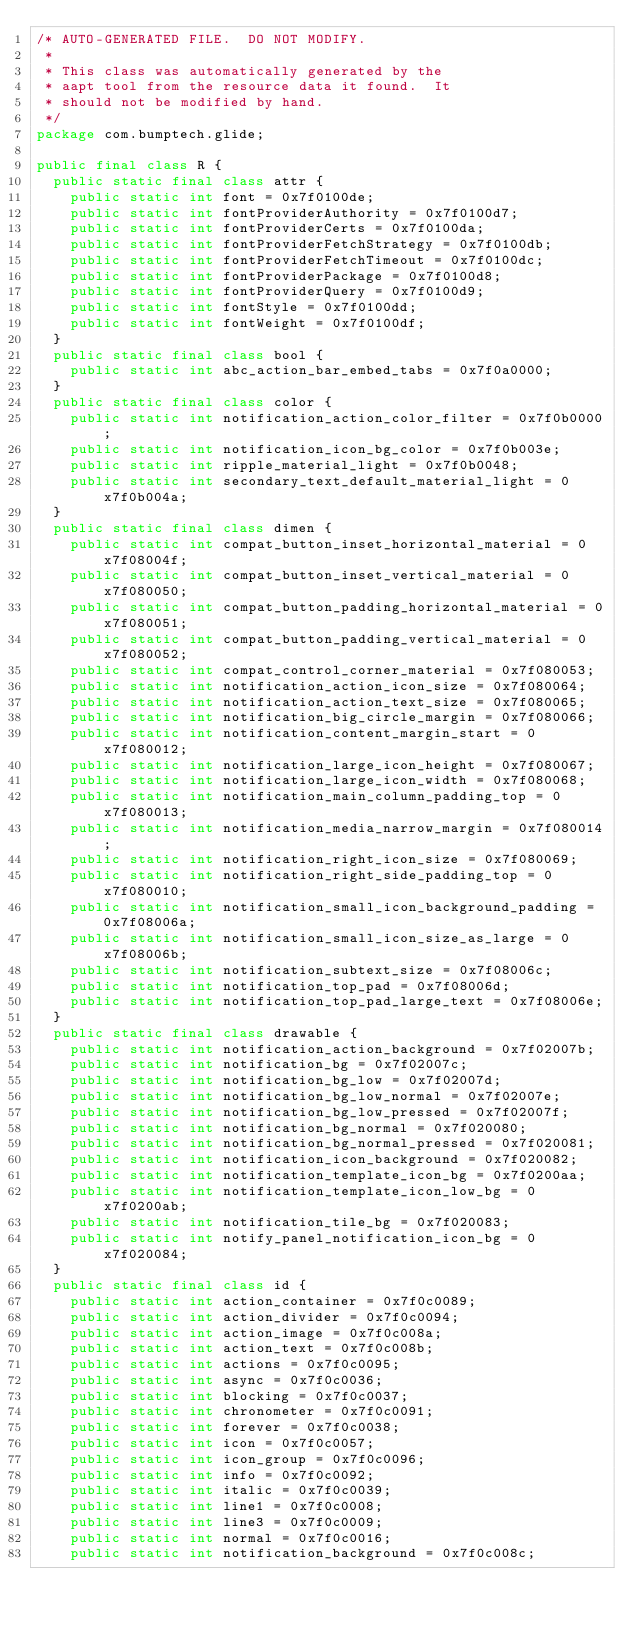<code> <loc_0><loc_0><loc_500><loc_500><_Java_>/* AUTO-GENERATED FILE.  DO NOT MODIFY.
 *
 * This class was automatically generated by the
 * aapt tool from the resource data it found.  It
 * should not be modified by hand.
 */
package com.bumptech.glide;

public final class R {
	public static final class attr {
		public static int font = 0x7f0100de;
		public static int fontProviderAuthority = 0x7f0100d7;
		public static int fontProviderCerts = 0x7f0100da;
		public static int fontProviderFetchStrategy = 0x7f0100db;
		public static int fontProviderFetchTimeout = 0x7f0100dc;
		public static int fontProviderPackage = 0x7f0100d8;
		public static int fontProviderQuery = 0x7f0100d9;
		public static int fontStyle = 0x7f0100dd;
		public static int fontWeight = 0x7f0100df;
	}
	public static final class bool {
		public static int abc_action_bar_embed_tabs = 0x7f0a0000;
	}
	public static final class color {
		public static int notification_action_color_filter = 0x7f0b0000;
		public static int notification_icon_bg_color = 0x7f0b003e;
		public static int ripple_material_light = 0x7f0b0048;
		public static int secondary_text_default_material_light = 0x7f0b004a;
	}
	public static final class dimen {
		public static int compat_button_inset_horizontal_material = 0x7f08004f;
		public static int compat_button_inset_vertical_material = 0x7f080050;
		public static int compat_button_padding_horizontal_material = 0x7f080051;
		public static int compat_button_padding_vertical_material = 0x7f080052;
		public static int compat_control_corner_material = 0x7f080053;
		public static int notification_action_icon_size = 0x7f080064;
		public static int notification_action_text_size = 0x7f080065;
		public static int notification_big_circle_margin = 0x7f080066;
		public static int notification_content_margin_start = 0x7f080012;
		public static int notification_large_icon_height = 0x7f080067;
		public static int notification_large_icon_width = 0x7f080068;
		public static int notification_main_column_padding_top = 0x7f080013;
		public static int notification_media_narrow_margin = 0x7f080014;
		public static int notification_right_icon_size = 0x7f080069;
		public static int notification_right_side_padding_top = 0x7f080010;
		public static int notification_small_icon_background_padding = 0x7f08006a;
		public static int notification_small_icon_size_as_large = 0x7f08006b;
		public static int notification_subtext_size = 0x7f08006c;
		public static int notification_top_pad = 0x7f08006d;
		public static int notification_top_pad_large_text = 0x7f08006e;
	}
	public static final class drawable {
		public static int notification_action_background = 0x7f02007b;
		public static int notification_bg = 0x7f02007c;
		public static int notification_bg_low = 0x7f02007d;
		public static int notification_bg_low_normal = 0x7f02007e;
		public static int notification_bg_low_pressed = 0x7f02007f;
		public static int notification_bg_normal = 0x7f020080;
		public static int notification_bg_normal_pressed = 0x7f020081;
		public static int notification_icon_background = 0x7f020082;
		public static int notification_template_icon_bg = 0x7f0200aa;
		public static int notification_template_icon_low_bg = 0x7f0200ab;
		public static int notification_tile_bg = 0x7f020083;
		public static int notify_panel_notification_icon_bg = 0x7f020084;
	}
	public static final class id {
		public static int action_container = 0x7f0c0089;
		public static int action_divider = 0x7f0c0094;
		public static int action_image = 0x7f0c008a;
		public static int action_text = 0x7f0c008b;
		public static int actions = 0x7f0c0095;
		public static int async = 0x7f0c0036;
		public static int blocking = 0x7f0c0037;
		public static int chronometer = 0x7f0c0091;
		public static int forever = 0x7f0c0038;
		public static int icon = 0x7f0c0057;
		public static int icon_group = 0x7f0c0096;
		public static int info = 0x7f0c0092;
		public static int italic = 0x7f0c0039;
		public static int line1 = 0x7f0c0008;
		public static int line3 = 0x7f0c0009;
		public static int normal = 0x7f0c0016;
		public static int notification_background = 0x7f0c008c;</code> 